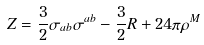<formula> <loc_0><loc_0><loc_500><loc_500>Z = \frac { 3 } { 2 } \sigma _ { a b } \sigma ^ { a b } - \frac { 3 } { 2 } R + 2 4 \pi \rho ^ { M }</formula> 